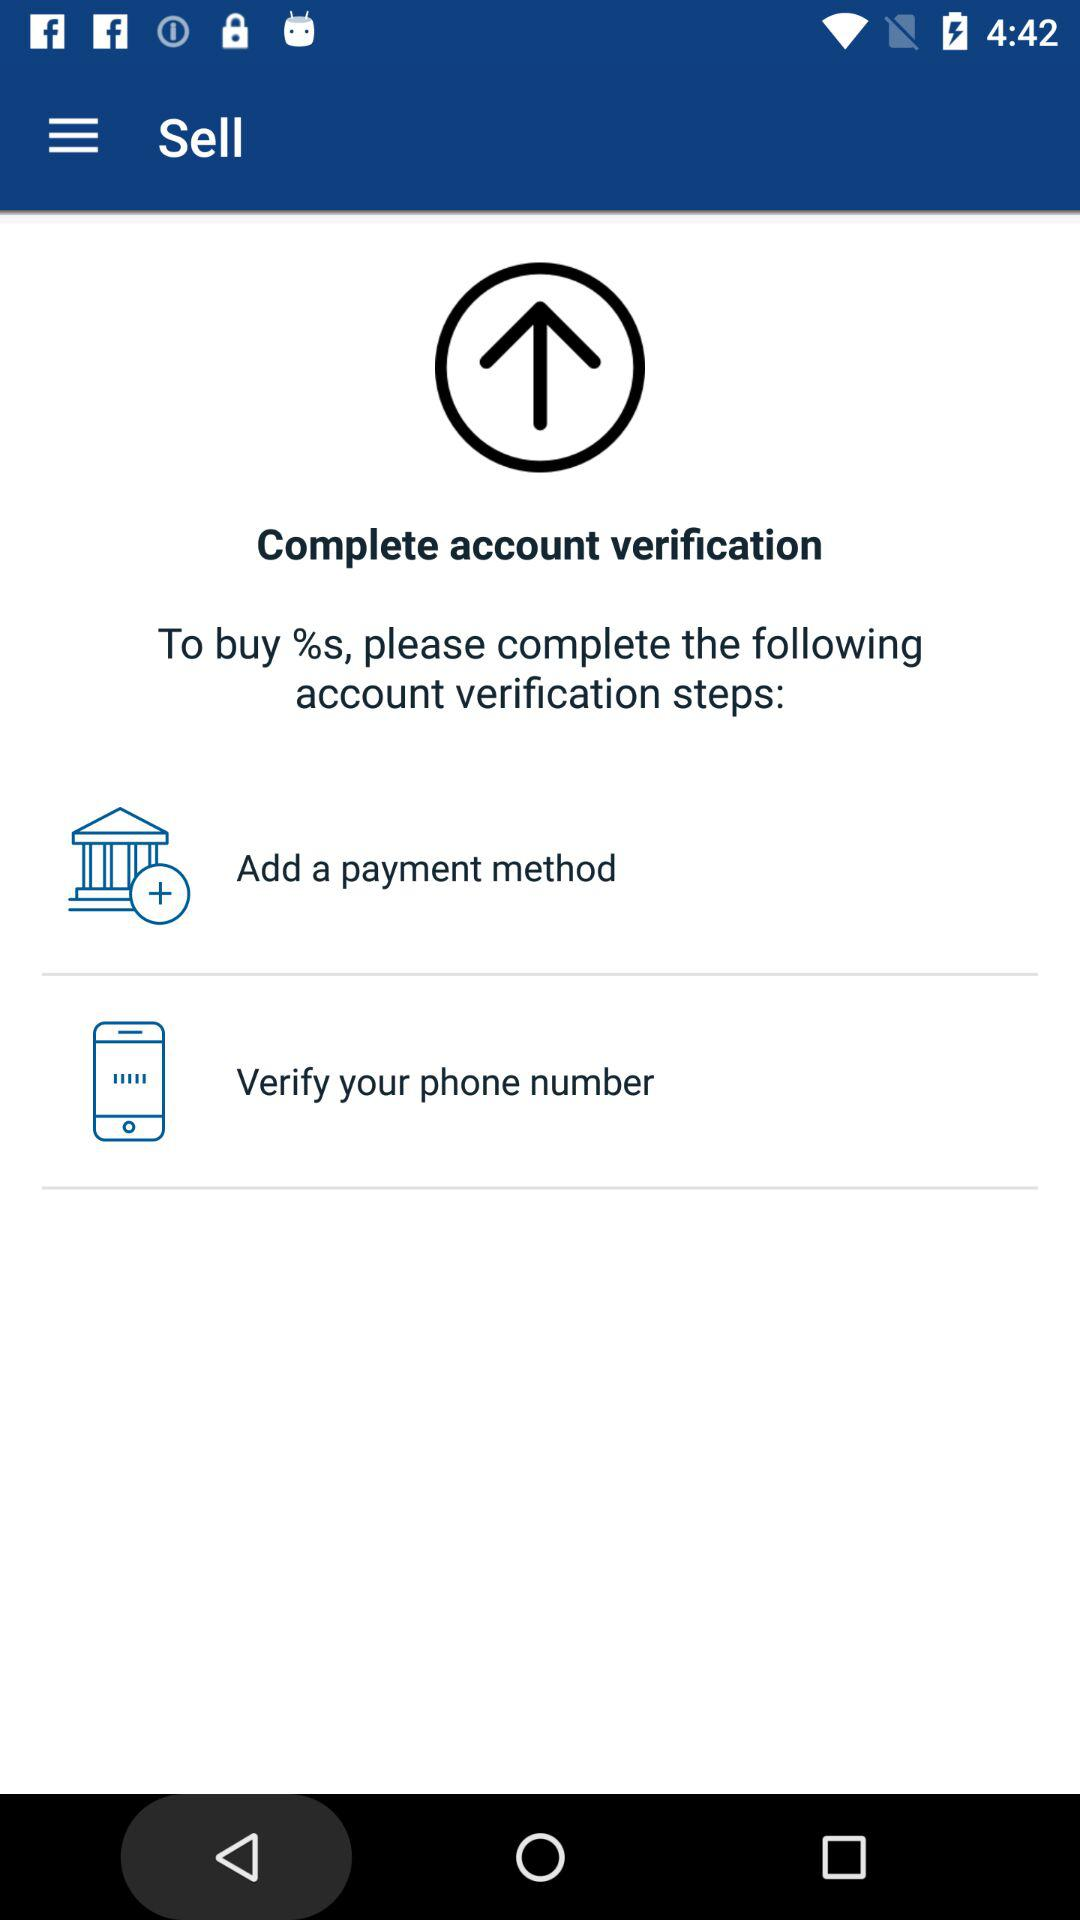How many text fields are there in the sign up form?
Answer the question using a single word or phrase. 4 